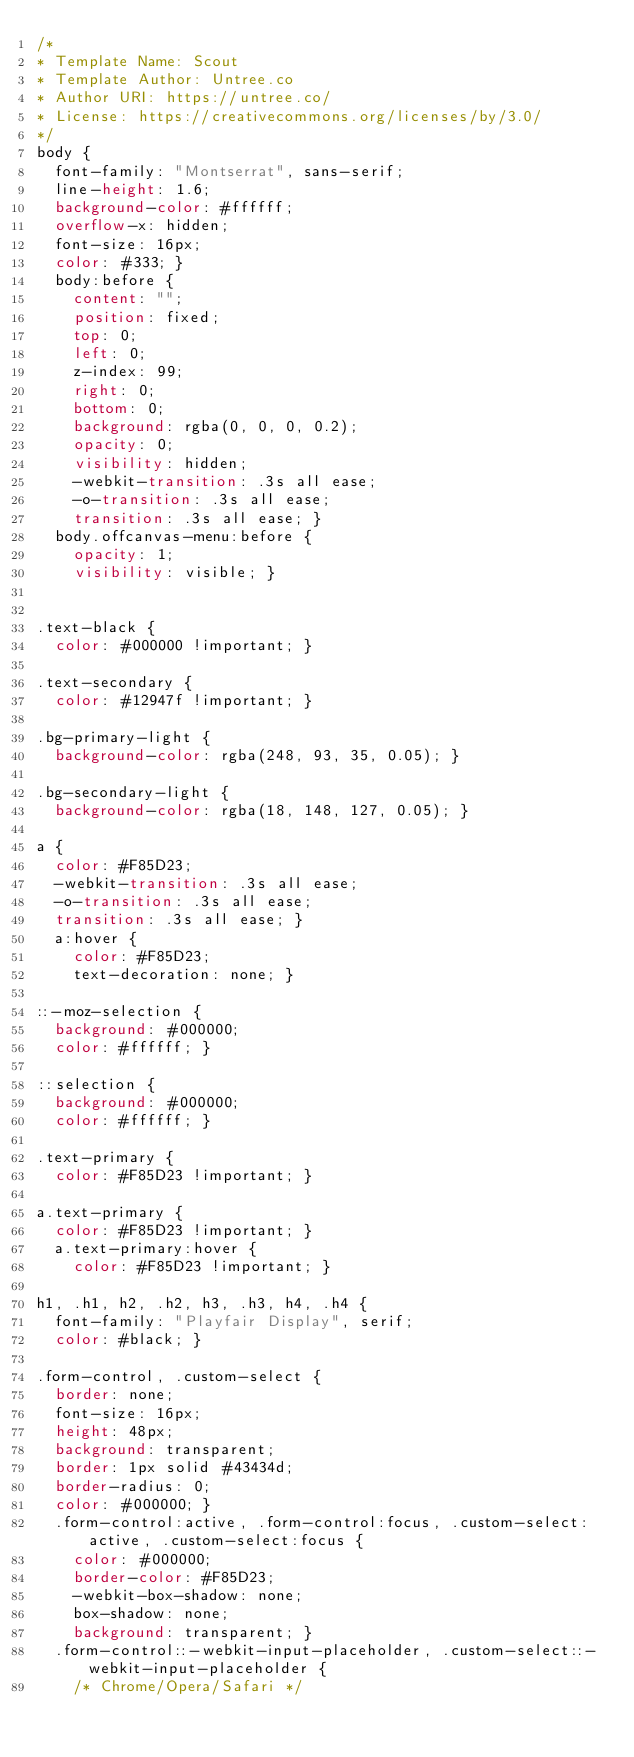Convert code to text. <code><loc_0><loc_0><loc_500><loc_500><_CSS_>/*
* Template Name: Scout
* Template Author: Untree.co
* Author URI: https://untree.co/
* License: https://creativecommons.org/licenses/by/3.0/
*/
body {
  font-family: "Montserrat", sans-serif;
  line-height: 1.6;
  background-color: #ffffff;
  overflow-x: hidden;
  font-size: 16px;
  color: #333; }
  body:before {
    content: "";
    position: fixed;
    top: 0;
    left: 0;
    z-index: 99;
    right: 0;
    bottom: 0;
    background: rgba(0, 0, 0, 0.2);
    opacity: 0;
    visibility: hidden;
    -webkit-transition: .3s all ease;
    -o-transition: .3s all ease;
    transition: .3s all ease; }
  body.offcanvas-menu:before {
    opacity: 1;
    visibility: visible; }

    
.text-black {
  color: #000000 !important; }

.text-secondary {
  color: #12947f !important; }

.bg-primary-light {
  background-color: rgba(248, 93, 35, 0.05); }

.bg-secondary-light {
  background-color: rgba(18, 148, 127, 0.05); }

a {
  color: #F85D23;
  -webkit-transition: .3s all ease;
  -o-transition: .3s all ease;
  transition: .3s all ease; }
  a:hover {
    color: #F85D23;
    text-decoration: none; }

::-moz-selection {
  background: #000000;
  color: #ffffff; }

::selection {
  background: #000000;
  color: #ffffff; }

.text-primary {
  color: #F85D23 !important; }

a.text-primary {
  color: #F85D23 !important; }
  a.text-primary:hover {
    color: #F85D23 !important; }

h1, .h1, h2, .h2, h3, .h3, h4, .h4 {
  font-family: "Playfair Display", serif;
  color: #black; }

.form-control, .custom-select {
  border: none;
  font-size: 16px;
  height: 48px;
  background: transparent;
  border: 1px solid #43434d;
  border-radius: 0;
  color: #000000; }
  .form-control:active, .form-control:focus, .custom-select:active, .custom-select:focus {
    color: #000000;
    border-color: #F85D23;
    -webkit-box-shadow: none;
    box-shadow: none;
    background: transparent; }
  .form-control::-webkit-input-placeholder, .custom-select::-webkit-input-placeholder {
    /* Chrome/Opera/Safari */</code> 